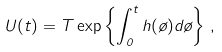Convert formula to latex. <formula><loc_0><loc_0><loc_500><loc_500>U ( t ) = T \exp \left \{ \int _ { 0 } ^ { t } h ( \tau ) d \tau \right \} \, ,</formula> 